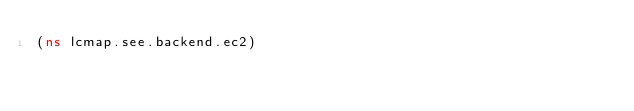Convert code to text. <code><loc_0><loc_0><loc_500><loc_500><_Clojure_>(ns lcmap.see.backend.ec2)
</code> 